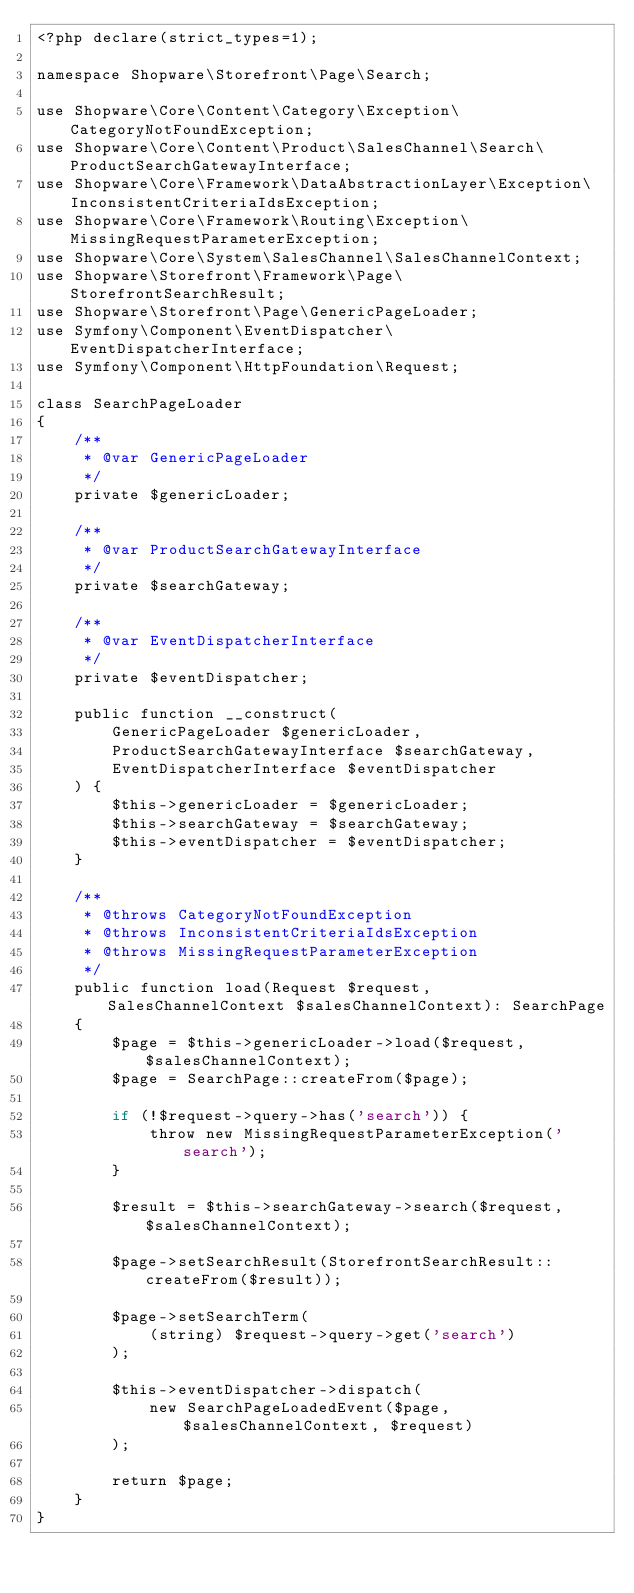Convert code to text. <code><loc_0><loc_0><loc_500><loc_500><_PHP_><?php declare(strict_types=1);

namespace Shopware\Storefront\Page\Search;

use Shopware\Core\Content\Category\Exception\CategoryNotFoundException;
use Shopware\Core\Content\Product\SalesChannel\Search\ProductSearchGatewayInterface;
use Shopware\Core\Framework\DataAbstractionLayer\Exception\InconsistentCriteriaIdsException;
use Shopware\Core\Framework\Routing\Exception\MissingRequestParameterException;
use Shopware\Core\System\SalesChannel\SalesChannelContext;
use Shopware\Storefront\Framework\Page\StorefrontSearchResult;
use Shopware\Storefront\Page\GenericPageLoader;
use Symfony\Component\EventDispatcher\EventDispatcherInterface;
use Symfony\Component\HttpFoundation\Request;

class SearchPageLoader
{
    /**
     * @var GenericPageLoader
     */
    private $genericLoader;

    /**
     * @var ProductSearchGatewayInterface
     */
    private $searchGateway;

    /**
     * @var EventDispatcherInterface
     */
    private $eventDispatcher;

    public function __construct(
        GenericPageLoader $genericLoader,
        ProductSearchGatewayInterface $searchGateway,
        EventDispatcherInterface $eventDispatcher
    ) {
        $this->genericLoader = $genericLoader;
        $this->searchGateway = $searchGateway;
        $this->eventDispatcher = $eventDispatcher;
    }

    /**
     * @throws CategoryNotFoundException
     * @throws InconsistentCriteriaIdsException
     * @throws MissingRequestParameterException
     */
    public function load(Request $request, SalesChannelContext $salesChannelContext): SearchPage
    {
        $page = $this->genericLoader->load($request, $salesChannelContext);
        $page = SearchPage::createFrom($page);

        if (!$request->query->has('search')) {
            throw new MissingRequestParameterException('search');
        }

        $result = $this->searchGateway->search($request, $salesChannelContext);

        $page->setSearchResult(StorefrontSearchResult::createFrom($result));

        $page->setSearchTerm(
            (string) $request->query->get('search')
        );

        $this->eventDispatcher->dispatch(
            new SearchPageLoadedEvent($page, $salesChannelContext, $request)
        );

        return $page;
    }
}
</code> 